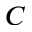<formula> <loc_0><loc_0><loc_500><loc_500>C</formula> 